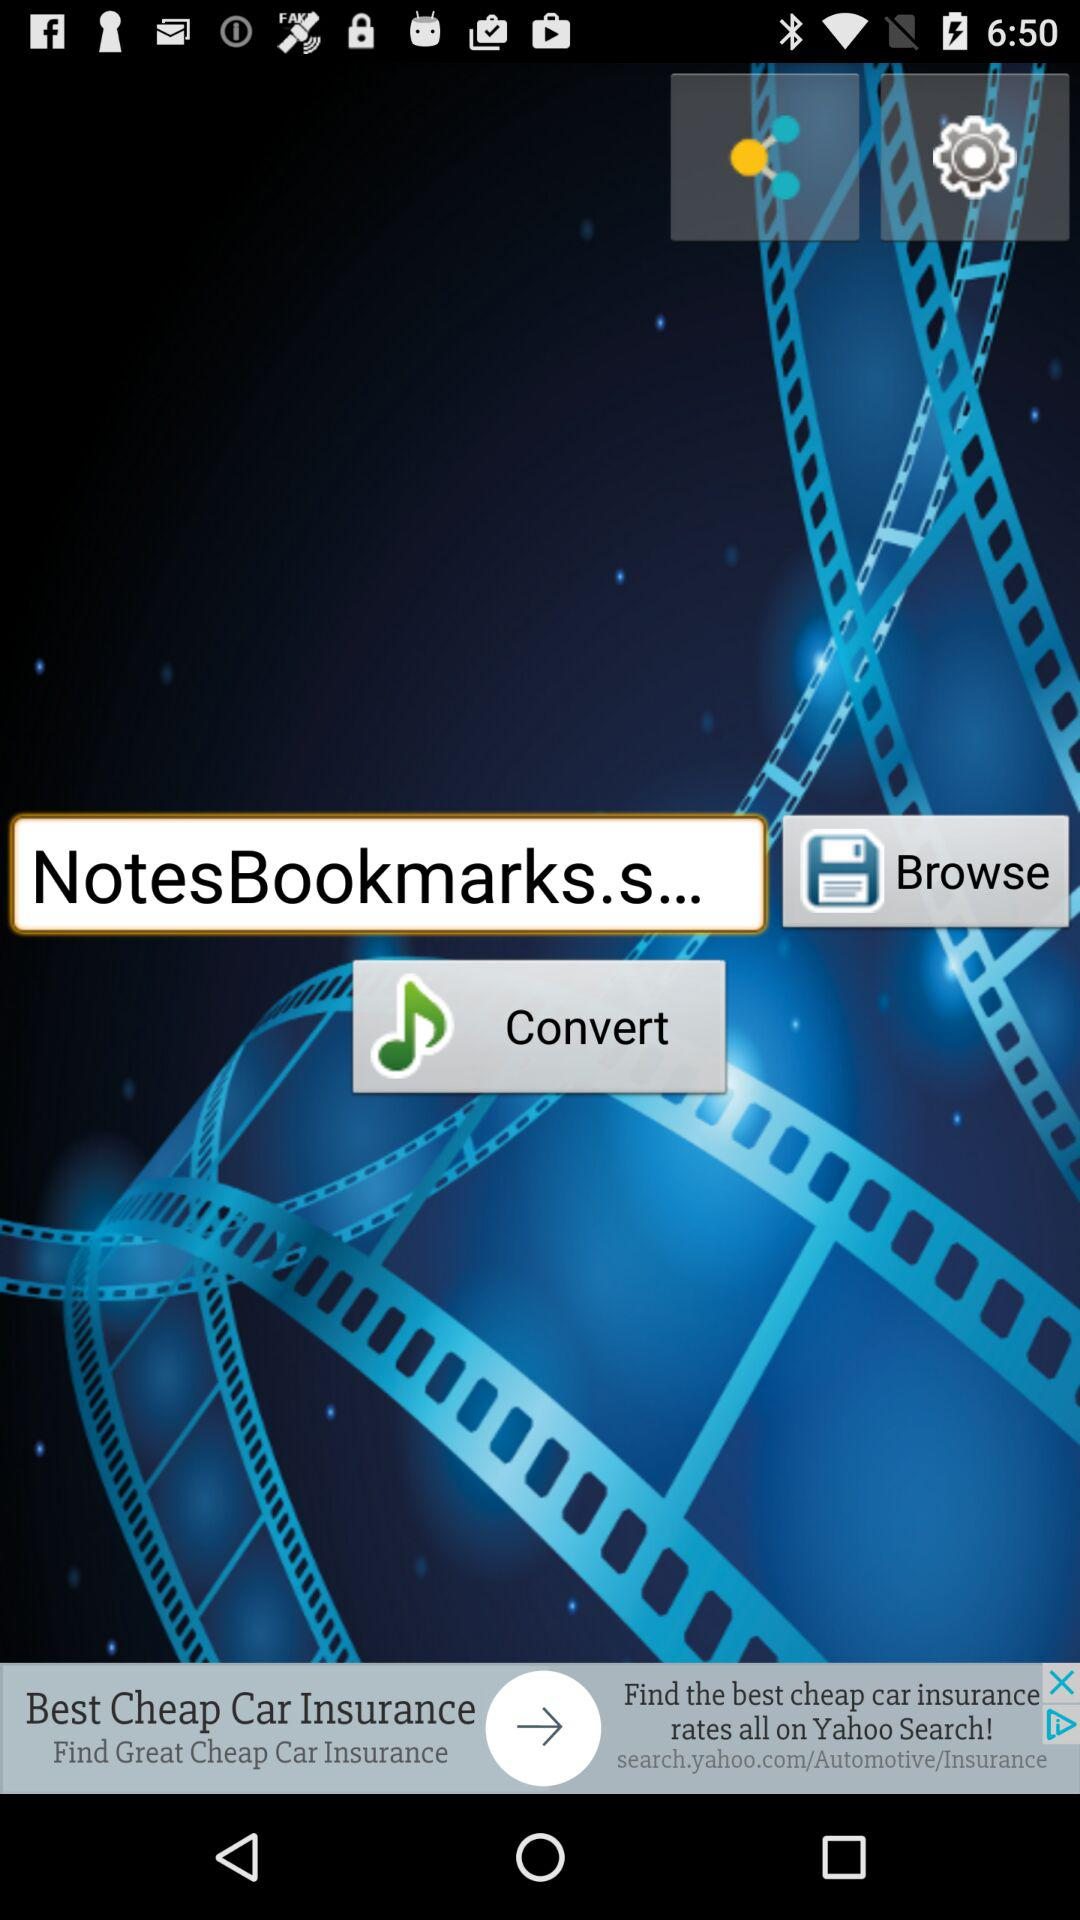Which music is selected to convert?
When the provided information is insufficient, respond with <no answer>. <no answer> 